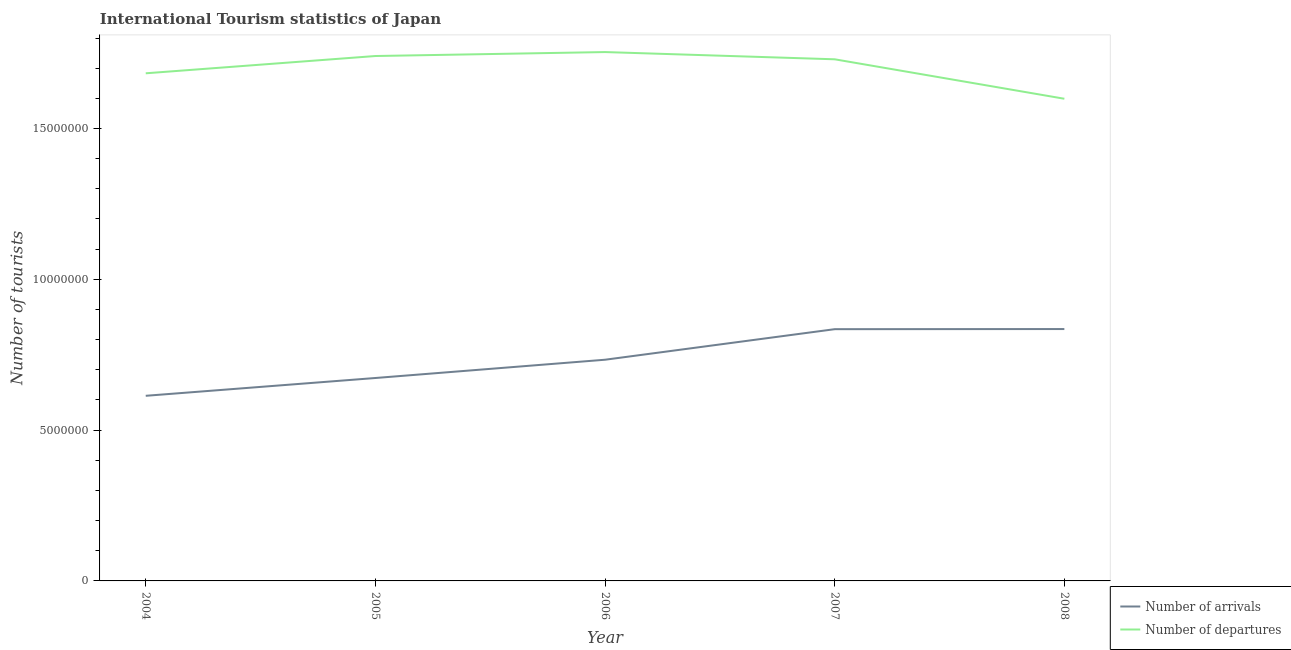What is the number of tourist arrivals in 2006?
Offer a terse response. 7.33e+06. Across all years, what is the maximum number of tourist arrivals?
Offer a terse response. 8.35e+06. Across all years, what is the minimum number of tourist arrivals?
Your answer should be very brief. 6.14e+06. In which year was the number of tourist departures minimum?
Make the answer very short. 2008. What is the total number of tourist departures in the graph?
Provide a short and direct response. 8.51e+07. What is the difference between the number of tourist arrivals in 2005 and that in 2006?
Make the answer very short. -6.06e+05. What is the difference between the number of tourist departures in 2004 and the number of tourist arrivals in 2007?
Your answer should be compact. 8.48e+06. What is the average number of tourist departures per year?
Ensure brevity in your answer.  1.70e+07. In the year 2007, what is the difference between the number of tourist departures and number of tourist arrivals?
Your answer should be compact. 8.95e+06. In how many years, is the number of tourist arrivals greater than 6000000?
Provide a succinct answer. 5. What is the ratio of the number of tourist arrivals in 2005 to that in 2006?
Provide a short and direct response. 0.92. Is the number of tourist arrivals in 2006 less than that in 2007?
Your answer should be very brief. Yes. Is the difference between the number of tourist departures in 2004 and 2008 greater than the difference between the number of tourist arrivals in 2004 and 2008?
Provide a succinct answer. Yes. What is the difference between the highest and the second highest number of tourist arrivals?
Your answer should be very brief. 4000. What is the difference between the highest and the lowest number of tourist arrivals?
Your answer should be very brief. 2.21e+06. In how many years, is the number of tourist arrivals greater than the average number of tourist arrivals taken over all years?
Keep it short and to the point. 2. Is the sum of the number of tourist arrivals in 2005 and 2007 greater than the maximum number of tourist departures across all years?
Your answer should be compact. No. Is the number of tourist arrivals strictly greater than the number of tourist departures over the years?
Give a very brief answer. No. How many years are there in the graph?
Your answer should be compact. 5. What is the difference between two consecutive major ticks on the Y-axis?
Offer a terse response. 5.00e+06. Are the values on the major ticks of Y-axis written in scientific E-notation?
Provide a short and direct response. No. Does the graph contain any zero values?
Provide a short and direct response. No. Does the graph contain grids?
Ensure brevity in your answer.  No. Where does the legend appear in the graph?
Keep it short and to the point. Bottom right. What is the title of the graph?
Your answer should be very brief. International Tourism statistics of Japan. What is the label or title of the X-axis?
Provide a short and direct response. Year. What is the label or title of the Y-axis?
Keep it short and to the point. Number of tourists. What is the Number of tourists in Number of arrivals in 2004?
Provide a succinct answer. 6.14e+06. What is the Number of tourists of Number of departures in 2004?
Keep it short and to the point. 1.68e+07. What is the Number of tourists in Number of arrivals in 2005?
Keep it short and to the point. 6.73e+06. What is the Number of tourists in Number of departures in 2005?
Offer a very short reply. 1.74e+07. What is the Number of tourists in Number of arrivals in 2006?
Ensure brevity in your answer.  7.33e+06. What is the Number of tourists in Number of departures in 2006?
Your answer should be very brief. 1.75e+07. What is the Number of tourists in Number of arrivals in 2007?
Make the answer very short. 8.35e+06. What is the Number of tourists in Number of departures in 2007?
Offer a very short reply. 1.73e+07. What is the Number of tourists of Number of arrivals in 2008?
Your response must be concise. 8.35e+06. What is the Number of tourists in Number of departures in 2008?
Your response must be concise. 1.60e+07. Across all years, what is the maximum Number of tourists of Number of arrivals?
Give a very brief answer. 8.35e+06. Across all years, what is the maximum Number of tourists in Number of departures?
Ensure brevity in your answer.  1.75e+07. Across all years, what is the minimum Number of tourists of Number of arrivals?
Keep it short and to the point. 6.14e+06. Across all years, what is the minimum Number of tourists in Number of departures?
Provide a succinct answer. 1.60e+07. What is the total Number of tourists of Number of arrivals in the graph?
Give a very brief answer. 3.69e+07. What is the total Number of tourists of Number of departures in the graph?
Offer a very short reply. 8.51e+07. What is the difference between the Number of tourists of Number of arrivals in 2004 and that in 2005?
Keep it short and to the point. -5.90e+05. What is the difference between the Number of tourists of Number of departures in 2004 and that in 2005?
Your answer should be very brief. -5.73e+05. What is the difference between the Number of tourists of Number of arrivals in 2004 and that in 2006?
Offer a very short reply. -1.20e+06. What is the difference between the Number of tourists in Number of departures in 2004 and that in 2006?
Make the answer very short. -7.04e+05. What is the difference between the Number of tourists in Number of arrivals in 2004 and that in 2007?
Keep it short and to the point. -2.21e+06. What is the difference between the Number of tourists in Number of departures in 2004 and that in 2007?
Provide a short and direct response. -4.64e+05. What is the difference between the Number of tourists in Number of arrivals in 2004 and that in 2008?
Provide a short and direct response. -2.21e+06. What is the difference between the Number of tourists of Number of departures in 2004 and that in 2008?
Keep it short and to the point. 8.44e+05. What is the difference between the Number of tourists in Number of arrivals in 2005 and that in 2006?
Your answer should be very brief. -6.06e+05. What is the difference between the Number of tourists in Number of departures in 2005 and that in 2006?
Provide a succinct answer. -1.31e+05. What is the difference between the Number of tourists in Number of arrivals in 2005 and that in 2007?
Offer a terse response. -1.62e+06. What is the difference between the Number of tourists of Number of departures in 2005 and that in 2007?
Keep it short and to the point. 1.09e+05. What is the difference between the Number of tourists of Number of arrivals in 2005 and that in 2008?
Ensure brevity in your answer.  -1.62e+06. What is the difference between the Number of tourists in Number of departures in 2005 and that in 2008?
Your answer should be very brief. 1.42e+06. What is the difference between the Number of tourists in Number of arrivals in 2006 and that in 2007?
Make the answer very short. -1.01e+06. What is the difference between the Number of tourists of Number of arrivals in 2006 and that in 2008?
Your answer should be compact. -1.02e+06. What is the difference between the Number of tourists of Number of departures in 2006 and that in 2008?
Your answer should be very brief. 1.55e+06. What is the difference between the Number of tourists of Number of arrivals in 2007 and that in 2008?
Give a very brief answer. -4000. What is the difference between the Number of tourists in Number of departures in 2007 and that in 2008?
Your answer should be very brief. 1.31e+06. What is the difference between the Number of tourists of Number of arrivals in 2004 and the Number of tourists of Number of departures in 2005?
Ensure brevity in your answer.  -1.13e+07. What is the difference between the Number of tourists of Number of arrivals in 2004 and the Number of tourists of Number of departures in 2006?
Provide a succinct answer. -1.14e+07. What is the difference between the Number of tourists of Number of arrivals in 2004 and the Number of tourists of Number of departures in 2007?
Your answer should be very brief. -1.12e+07. What is the difference between the Number of tourists in Number of arrivals in 2004 and the Number of tourists in Number of departures in 2008?
Your answer should be compact. -9.85e+06. What is the difference between the Number of tourists in Number of arrivals in 2005 and the Number of tourists in Number of departures in 2006?
Keep it short and to the point. -1.08e+07. What is the difference between the Number of tourists in Number of arrivals in 2005 and the Number of tourists in Number of departures in 2007?
Your answer should be very brief. -1.06e+07. What is the difference between the Number of tourists in Number of arrivals in 2005 and the Number of tourists in Number of departures in 2008?
Provide a short and direct response. -9.26e+06. What is the difference between the Number of tourists in Number of arrivals in 2006 and the Number of tourists in Number of departures in 2007?
Make the answer very short. -9.96e+06. What is the difference between the Number of tourists in Number of arrivals in 2006 and the Number of tourists in Number of departures in 2008?
Your response must be concise. -8.65e+06. What is the difference between the Number of tourists in Number of arrivals in 2007 and the Number of tourists in Number of departures in 2008?
Your answer should be compact. -7.64e+06. What is the average Number of tourists in Number of arrivals per year?
Make the answer very short. 7.38e+06. What is the average Number of tourists of Number of departures per year?
Provide a short and direct response. 1.70e+07. In the year 2004, what is the difference between the Number of tourists in Number of arrivals and Number of tourists in Number of departures?
Your answer should be very brief. -1.07e+07. In the year 2005, what is the difference between the Number of tourists of Number of arrivals and Number of tourists of Number of departures?
Your answer should be very brief. -1.07e+07. In the year 2006, what is the difference between the Number of tourists in Number of arrivals and Number of tourists in Number of departures?
Provide a short and direct response. -1.02e+07. In the year 2007, what is the difference between the Number of tourists of Number of arrivals and Number of tourists of Number of departures?
Offer a terse response. -8.95e+06. In the year 2008, what is the difference between the Number of tourists of Number of arrivals and Number of tourists of Number of departures?
Offer a very short reply. -7.64e+06. What is the ratio of the Number of tourists of Number of arrivals in 2004 to that in 2005?
Your answer should be very brief. 0.91. What is the ratio of the Number of tourists of Number of departures in 2004 to that in 2005?
Provide a succinct answer. 0.97. What is the ratio of the Number of tourists of Number of arrivals in 2004 to that in 2006?
Provide a short and direct response. 0.84. What is the ratio of the Number of tourists in Number of departures in 2004 to that in 2006?
Provide a succinct answer. 0.96. What is the ratio of the Number of tourists in Number of arrivals in 2004 to that in 2007?
Provide a succinct answer. 0.74. What is the ratio of the Number of tourists in Number of departures in 2004 to that in 2007?
Make the answer very short. 0.97. What is the ratio of the Number of tourists of Number of arrivals in 2004 to that in 2008?
Your response must be concise. 0.73. What is the ratio of the Number of tourists of Number of departures in 2004 to that in 2008?
Make the answer very short. 1.05. What is the ratio of the Number of tourists in Number of arrivals in 2005 to that in 2006?
Give a very brief answer. 0.92. What is the ratio of the Number of tourists in Number of arrivals in 2005 to that in 2007?
Your response must be concise. 0.81. What is the ratio of the Number of tourists in Number of arrivals in 2005 to that in 2008?
Your answer should be very brief. 0.81. What is the ratio of the Number of tourists of Number of departures in 2005 to that in 2008?
Your answer should be compact. 1.09. What is the ratio of the Number of tourists in Number of arrivals in 2006 to that in 2007?
Provide a succinct answer. 0.88. What is the ratio of the Number of tourists in Number of departures in 2006 to that in 2007?
Offer a terse response. 1.01. What is the ratio of the Number of tourists in Number of arrivals in 2006 to that in 2008?
Make the answer very short. 0.88. What is the ratio of the Number of tourists in Number of departures in 2006 to that in 2008?
Your response must be concise. 1.1. What is the ratio of the Number of tourists in Number of arrivals in 2007 to that in 2008?
Provide a short and direct response. 1. What is the ratio of the Number of tourists in Number of departures in 2007 to that in 2008?
Ensure brevity in your answer.  1.08. What is the difference between the highest and the second highest Number of tourists in Number of arrivals?
Offer a terse response. 4000. What is the difference between the highest and the second highest Number of tourists of Number of departures?
Ensure brevity in your answer.  1.31e+05. What is the difference between the highest and the lowest Number of tourists of Number of arrivals?
Provide a succinct answer. 2.21e+06. What is the difference between the highest and the lowest Number of tourists of Number of departures?
Make the answer very short. 1.55e+06. 